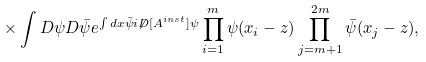<formula> <loc_0><loc_0><loc_500><loc_500>\times \int D \psi D \bar { \psi } e ^ { \int d x \bar { \psi } i \not D [ A ^ { i n s t } ] \psi } \prod _ { i = 1 } ^ { m } \psi ( x _ { i } - z ) \prod _ { j = m + 1 } ^ { 2 m } \bar { \psi } ( x _ { j } - z ) ,</formula> 